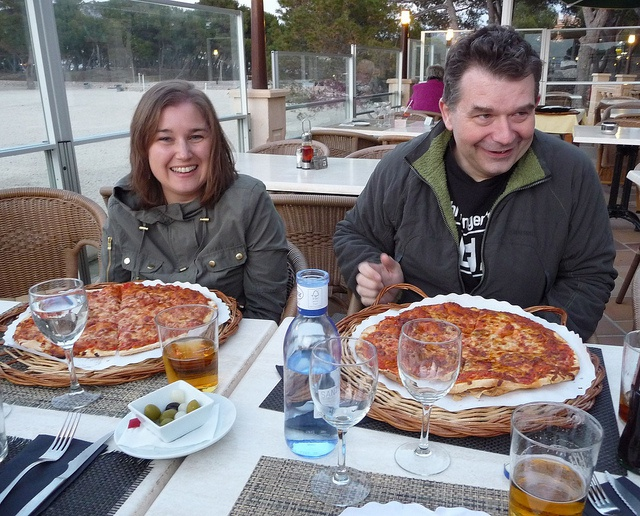Describe the objects in this image and their specific colors. I can see people in gray, black, and lightpink tones, dining table in gray, lightgray, darkgray, and navy tones, people in gray, black, and maroon tones, pizza in gray, brown, and tan tones, and cup in gray, darkgray, and olive tones in this image. 